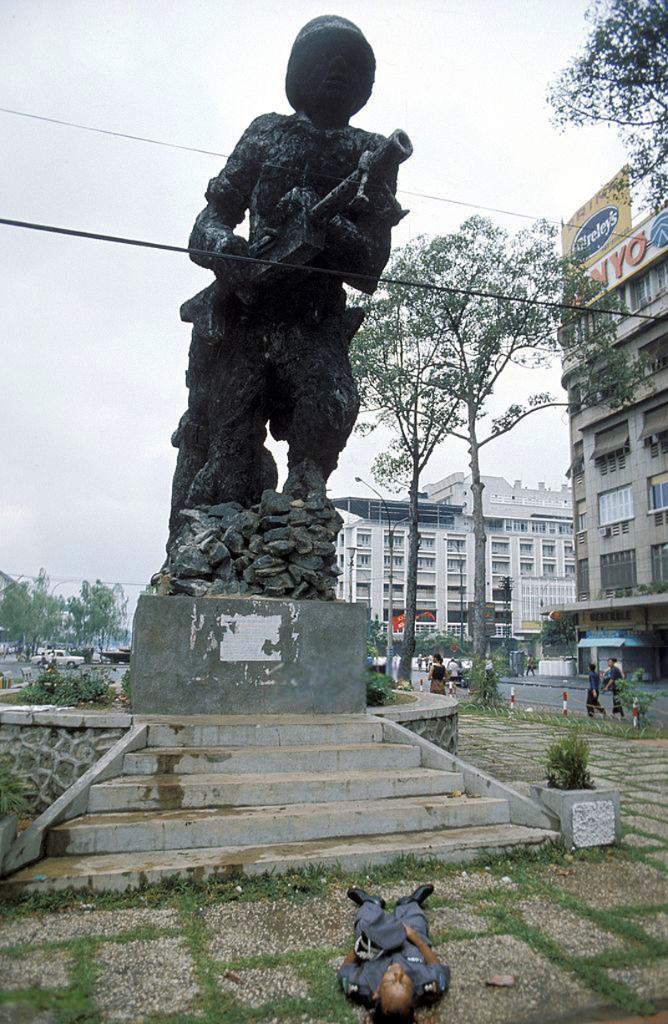In one or two sentences, can you explain what this image depicts? In the middle of this image, there is a statue of a person on a platform. Beside this statue, there are two cables. At the bottom of this image, there is a person in a uniform lying on the ground, on which there is grass. In the background, there are buildings, trees, vehicles, persons and there are clouds in the sky. 